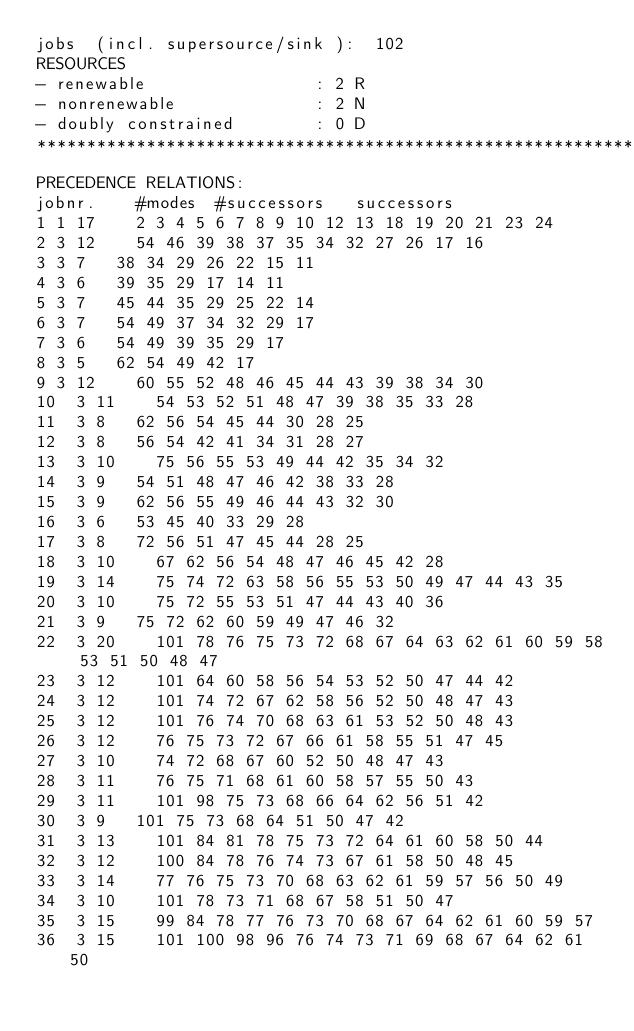Convert code to text. <code><loc_0><loc_0><loc_500><loc_500><_ObjectiveC_>jobs  (incl. supersource/sink ):	102
RESOURCES
- renewable                 : 2 R
- nonrenewable              : 2 N
- doubly constrained        : 0 D
************************************************************************
PRECEDENCE RELATIONS:
jobnr.    #modes  #successors   successors
1	1	17		2 3 4 5 6 7 8 9 10 12 13 18 19 20 21 23 24 
2	3	12		54 46 39 38 37 35 34 32 27 26 17 16 
3	3	7		38 34 29 26 22 15 11 
4	3	6		39 35 29 17 14 11 
5	3	7		45 44 35 29 25 22 14 
6	3	7		54 49 37 34 32 29 17 
7	3	6		54 49 39 35 29 17 
8	3	5		62 54 49 42 17 
9	3	12		60 55 52 48 46 45 44 43 39 38 34 30 
10	3	11		54 53 52 51 48 47 39 38 35 33 28 
11	3	8		62 56 54 45 44 30 28 25 
12	3	8		56 54 42 41 34 31 28 27 
13	3	10		75 56 55 53 49 44 42 35 34 32 
14	3	9		54 51 48 47 46 42 38 33 28 
15	3	9		62 56 55 49 46 44 43 32 30 
16	3	6		53 45 40 33 29 28 
17	3	8		72 56 51 47 45 44 28 25 
18	3	10		67 62 56 54 48 47 46 45 42 28 
19	3	14		75 74 72 63 58 56 55 53 50 49 47 44 43 35 
20	3	10		75 72 55 53 51 47 44 43 40 36 
21	3	9		75 72 62 60 59 49 47 46 32 
22	3	20		101 78 76 75 73 72 68 67 64 63 62 61 60 59 58 53 51 50 48 47 
23	3	12		101 64 60 58 56 54 53 52 50 47 44 42 
24	3	12		101 74 72 67 62 58 56 52 50 48 47 43 
25	3	12		101 76 74 70 68 63 61 53 52 50 48 43 
26	3	12		76 75 73 72 67 66 61 58 55 51 47 45 
27	3	10		74 72 68 67 60 52 50 48 47 43 
28	3	11		76 75 71 68 61 60 58 57 55 50 43 
29	3	11		101 98 75 73 68 66 64 62 56 51 42 
30	3	9		101 75 73 68 64 51 50 47 42 
31	3	13		101 84 81 78 75 73 72 64 61 60 58 50 44 
32	3	12		100 84 78 76 74 73 67 61 58 50 48 45 
33	3	14		77 76 75 73 70 68 63 62 61 59 57 56 50 49 
34	3	10		101 78 73 71 68 67 58 51 50 47 
35	3	15		99 84 78 77 76 73 70 68 67 64 62 61 60 59 57 
36	3	15		101 100 98 96 76 74 73 71 69 68 67 64 62 61 50 </code> 